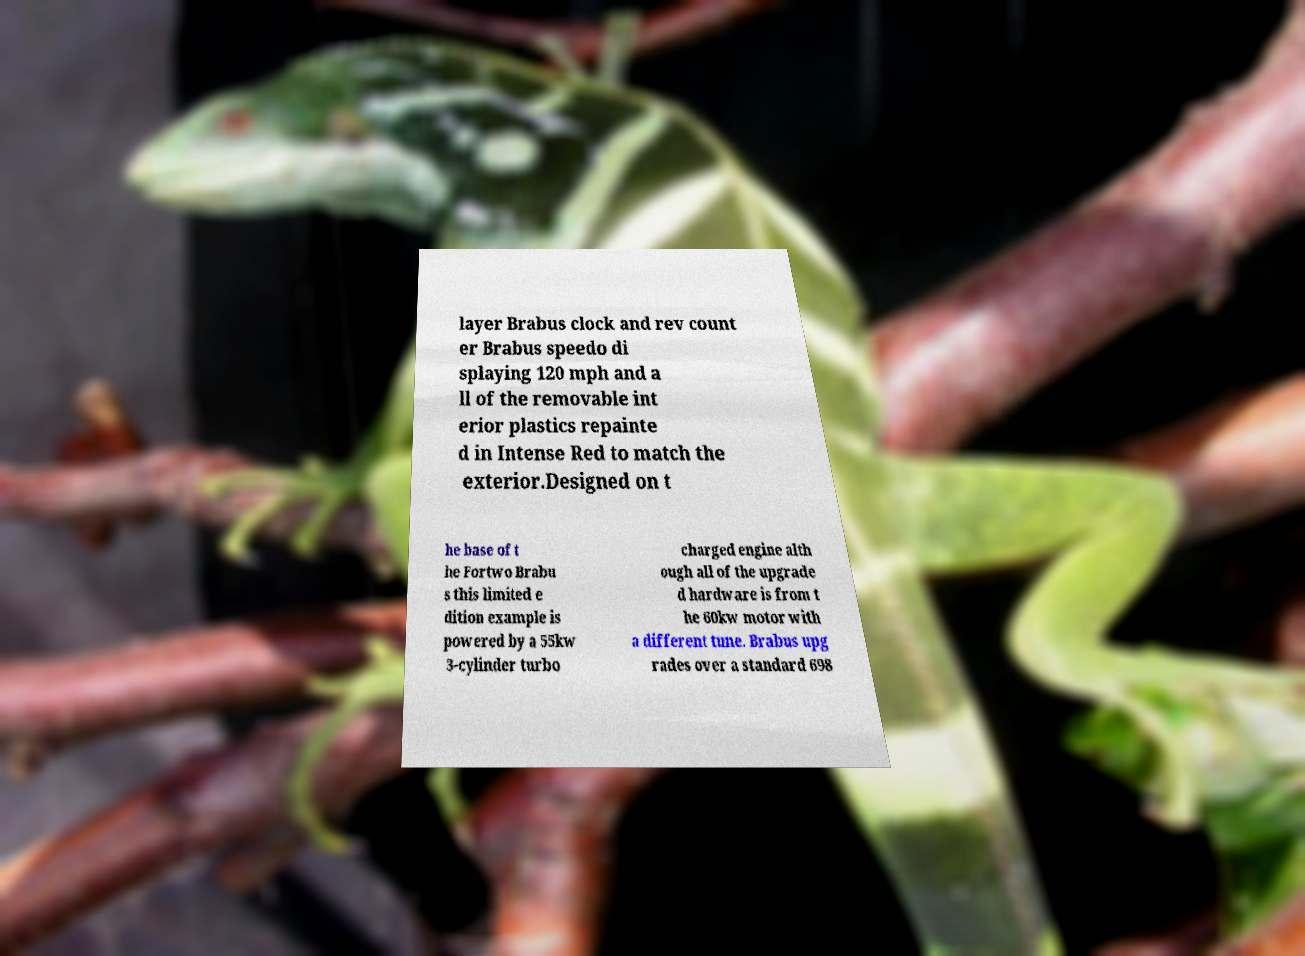Can you accurately transcribe the text from the provided image for me? layer Brabus clock and rev count er Brabus speedo di splaying 120 mph and a ll of the removable int erior plastics repainte d in Intense Red to match the exterior.Designed on t he base of t he Fortwo Brabu s this limited e dition example is powered by a 55kw 3-cylinder turbo charged engine alth ough all of the upgrade d hardware is from t he 60kw motor with a different tune. Brabus upg rades over a standard 698 